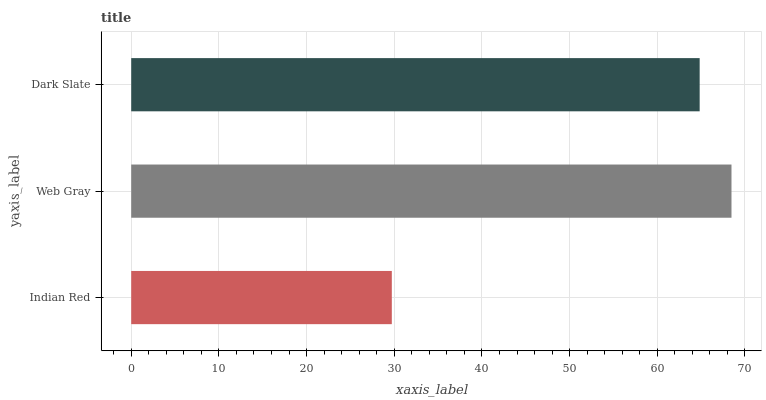Is Indian Red the minimum?
Answer yes or no. Yes. Is Web Gray the maximum?
Answer yes or no. Yes. Is Dark Slate the minimum?
Answer yes or no. No. Is Dark Slate the maximum?
Answer yes or no. No. Is Web Gray greater than Dark Slate?
Answer yes or no. Yes. Is Dark Slate less than Web Gray?
Answer yes or no. Yes. Is Dark Slate greater than Web Gray?
Answer yes or no. No. Is Web Gray less than Dark Slate?
Answer yes or no. No. Is Dark Slate the high median?
Answer yes or no. Yes. Is Dark Slate the low median?
Answer yes or no. Yes. Is Web Gray the high median?
Answer yes or no. No. Is Web Gray the low median?
Answer yes or no. No. 